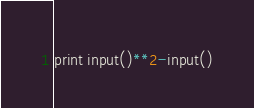Convert code to text. <code><loc_0><loc_0><loc_500><loc_500><_Python_>print input()**2-input()</code> 